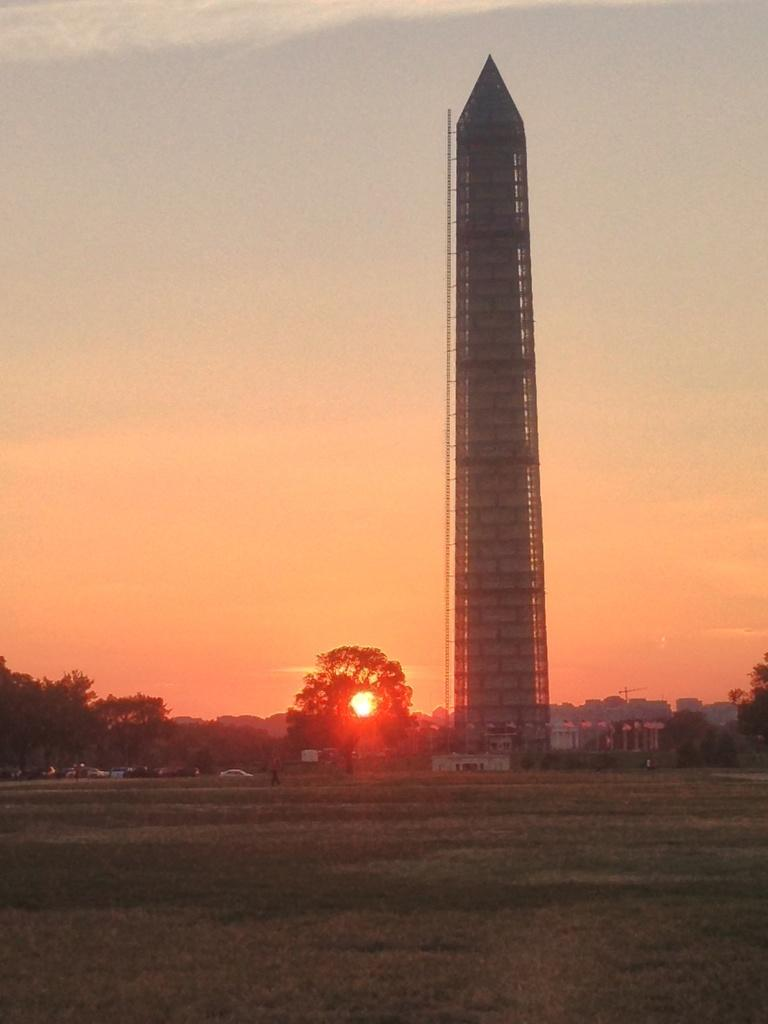What is the main structure in the image? There is a tower in the image. What type of vegetation surrounds the tower? Trees are present on either side of the tower. What is the ground cover in front of the tower? The front land is covered with grass. What can be seen in the sky in the image? The sky is visible in the image. How is the sun positioned in relation to the trees? The sun is behind the tree in the image. What color is the fifth tree in the image? There are only two trees mentioned in the facts, so there is no fifth tree in the image. 